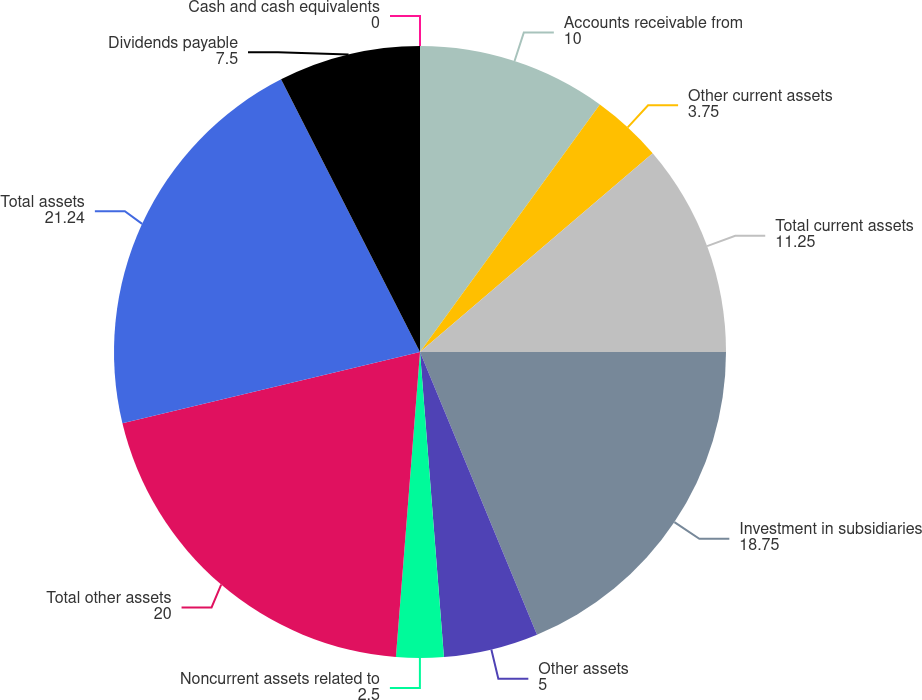<chart> <loc_0><loc_0><loc_500><loc_500><pie_chart><fcel>Cash and cash equivalents<fcel>Accounts receivable from<fcel>Other current assets<fcel>Total current assets<fcel>Investment in subsidiaries<fcel>Other assets<fcel>Noncurrent assets related to<fcel>Total other assets<fcel>Total assets<fcel>Dividends payable<nl><fcel>0.0%<fcel>10.0%<fcel>3.75%<fcel>11.25%<fcel>18.75%<fcel>5.0%<fcel>2.5%<fcel>20.0%<fcel>21.24%<fcel>7.5%<nl></chart> 